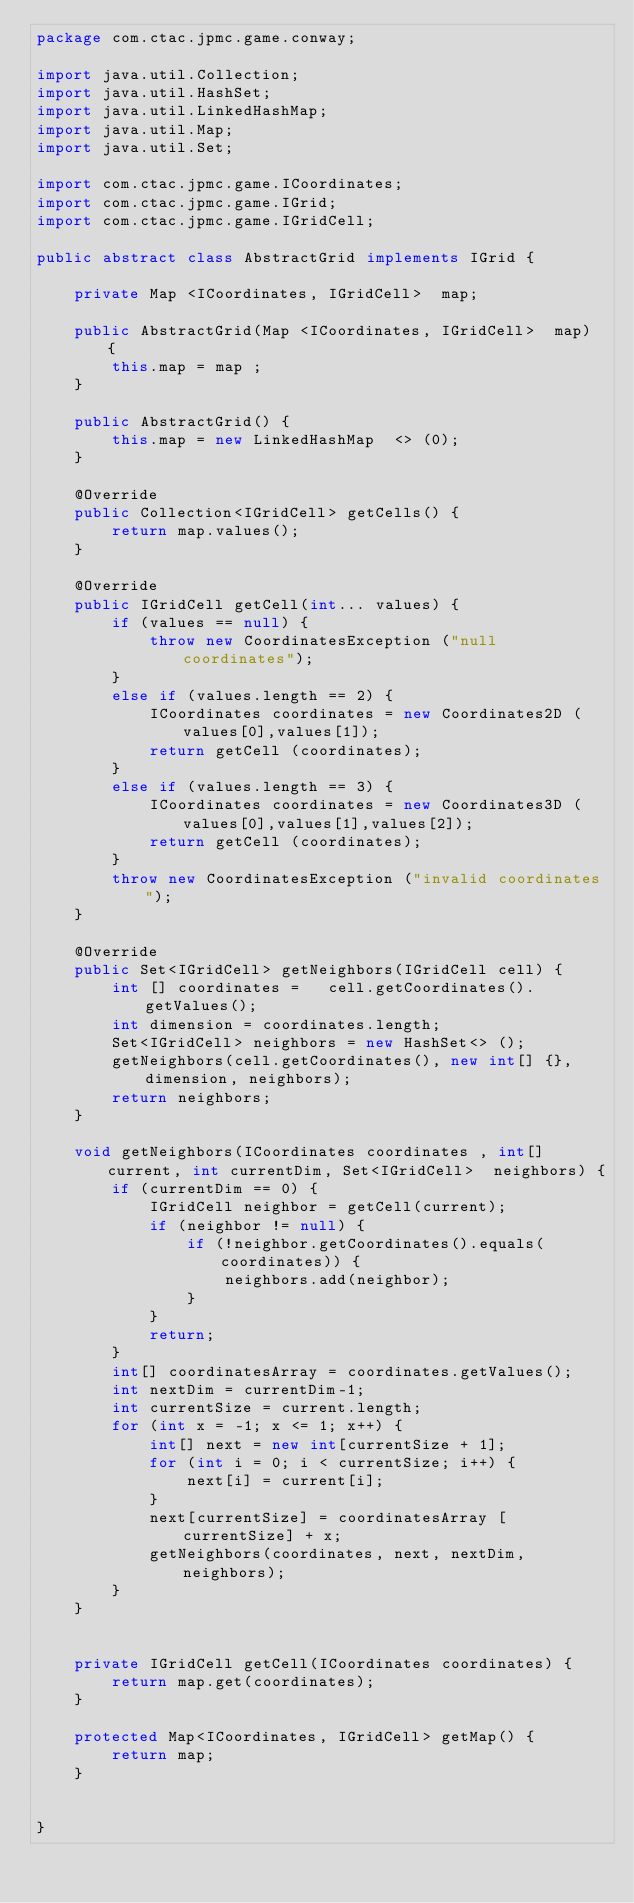Convert code to text. <code><loc_0><loc_0><loc_500><loc_500><_Java_>package com.ctac.jpmc.game.conway;

import java.util.Collection;
import java.util.HashSet;
import java.util.LinkedHashMap;
import java.util.Map;
import java.util.Set;

import com.ctac.jpmc.game.ICoordinates;
import com.ctac.jpmc.game.IGrid;
import com.ctac.jpmc.game.IGridCell;

public abstract class AbstractGrid implements IGrid {
	
	private Map <ICoordinates, IGridCell>  map;
	
	public AbstractGrid(Map <ICoordinates, IGridCell>  map) {
		this.map = map ;
	}
	
	public AbstractGrid() {
		this.map = new LinkedHashMap  <> (0);
	}

	@Override
	public Collection<IGridCell> getCells() { 
		return map.values();
	}

	@Override
	public IGridCell getCell(int... values) {
		if (values == null) {
			throw new CoordinatesException ("null coordinates");
		}
		else if (values.length == 2) {
			ICoordinates coordinates = new Coordinates2D (values[0],values[1]);
			return getCell (coordinates);
		}
		else if (values.length == 3) {
			ICoordinates coordinates = new Coordinates3D (values[0],values[1],values[2]);
			return getCell (coordinates);
		}
		throw new CoordinatesException ("invalid coordinates");
	}

	@Override
	public Set<IGridCell> getNeighbors(IGridCell cell) {
		int [] coordinates =   cell.getCoordinates().getValues();
		int dimension = coordinates.length;
		Set<IGridCell> neighbors = new HashSet<> ();
		getNeighbors(cell.getCoordinates(), new int[] {}, dimension, neighbors);
		return neighbors;
	}
	
	void getNeighbors(ICoordinates coordinates , int[] current, int currentDim, Set<IGridCell>  neighbors) {
		if (currentDim == 0) {
			IGridCell neighbor = getCell(current);
			if (neighbor != null) {
				if (!neighbor.getCoordinates().equals(coordinates)) {
					neighbors.add(neighbor);
				}
			}
			return;
		}
		int[] coordinatesArray = coordinates.getValues();
		int nextDim = currentDim-1;
		int currentSize = current.length;
		for (int x = -1; x <= 1; x++) {
			int[] next = new int[currentSize + 1];
			for (int i = 0; i < currentSize; i++) {
				next[i] = current[i];
			}
			next[currentSize] = coordinatesArray [currentSize] + x;
			getNeighbors(coordinates, next, nextDim, neighbors);
		}
	}
	
	
	private IGridCell getCell(ICoordinates coordinates) {
		return map.get(coordinates);
	}

	protected Map<ICoordinates, IGridCell> getMap() {
		return map;
	}
	
	
}
</code> 